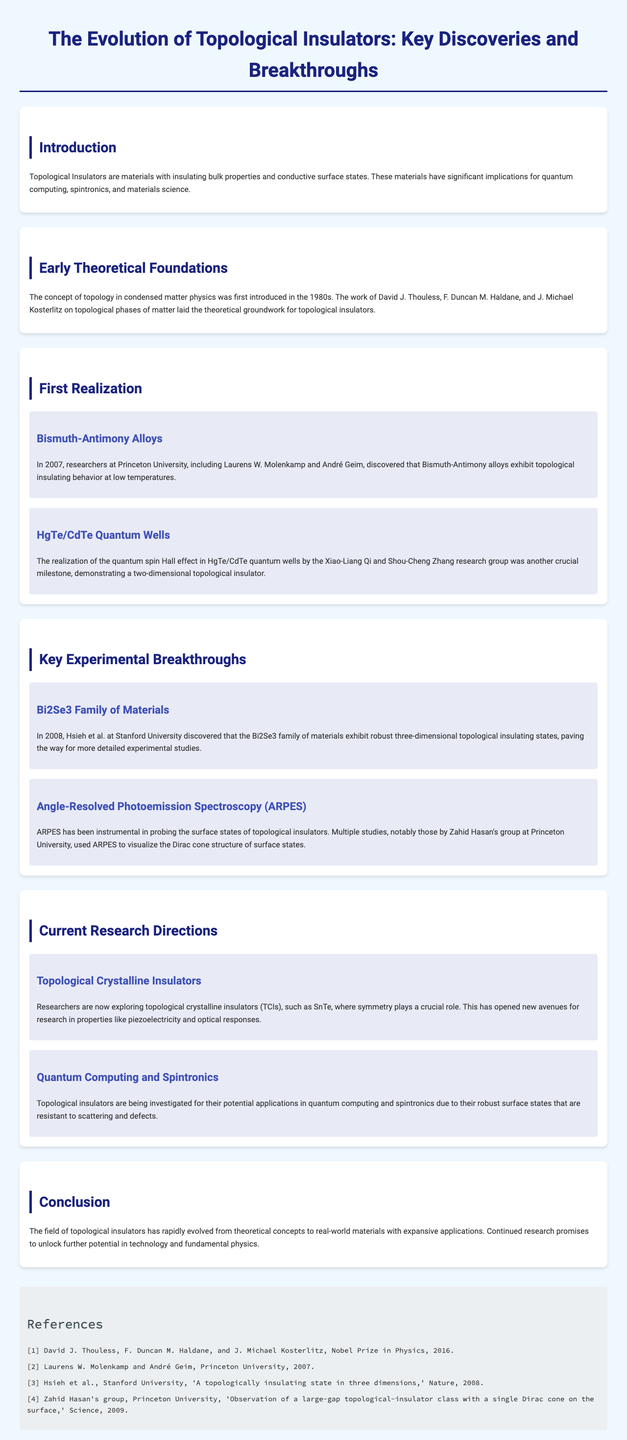What are Topological Insulators? Topological Insulators are defined as materials with insulating bulk properties and conductive surface states, according to the document.
Answer: Insulating bulk properties and conductive surface states Who laid the theoretical groundwork for topological insulators? The document states that David J. Thouless, F. Duncan M. Haldane, and J. Michael Kosterlitz were key figures in establishing the theoretical foundations.
Answer: David J. Thouless, F. Duncan M. Haldane, and J. Michael Kosterlitz What year did the first realization of topological insulators occur? The document notes that the first realization happened in 2007 with the discovery of Bismuth-Antimony alloys.
Answer: 2007 Which family of materials was discovered to exhibit robust three-dimensional topological insulating states? The document specifies that the Bi2Se3 family of materials was discovered to exhibit these states.
Answer: Bi2Se3 family What significant effect was demonstrated in HgTe/CdTe quantum wells? The realization of the quantum spin Hall effect is highlighted in the document as a significant breakthrough.
Answer: Quantum spin Hall effect What role does symmetry play in current research directions concerning Topological Crystalline Insulators? The document explains that symmetry plays a crucial role in the properties of Topological Crystalline Insulators.
Answer: Crucial role Which applications are topological insulators being investigated for? According to the document, topological insulators are being researched for potential applications in quantum computing and spintronics.
Answer: Quantum computing and spintronics What are the implications of continuing research in topological insulators? The document states that continued research promises to unlock further potential in technology and fundamental physics.
Answer: Unlock further potential in technology and fundamental physics 